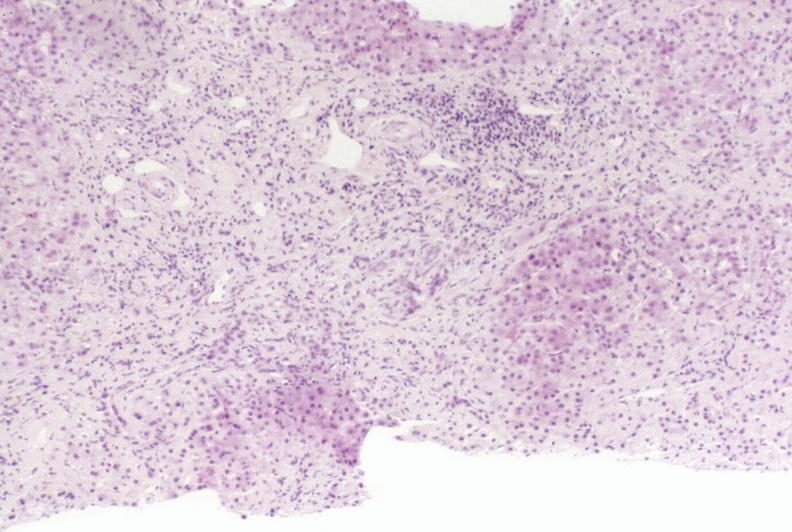s peritoneal fluid present?
Answer the question using a single word or phrase. No 